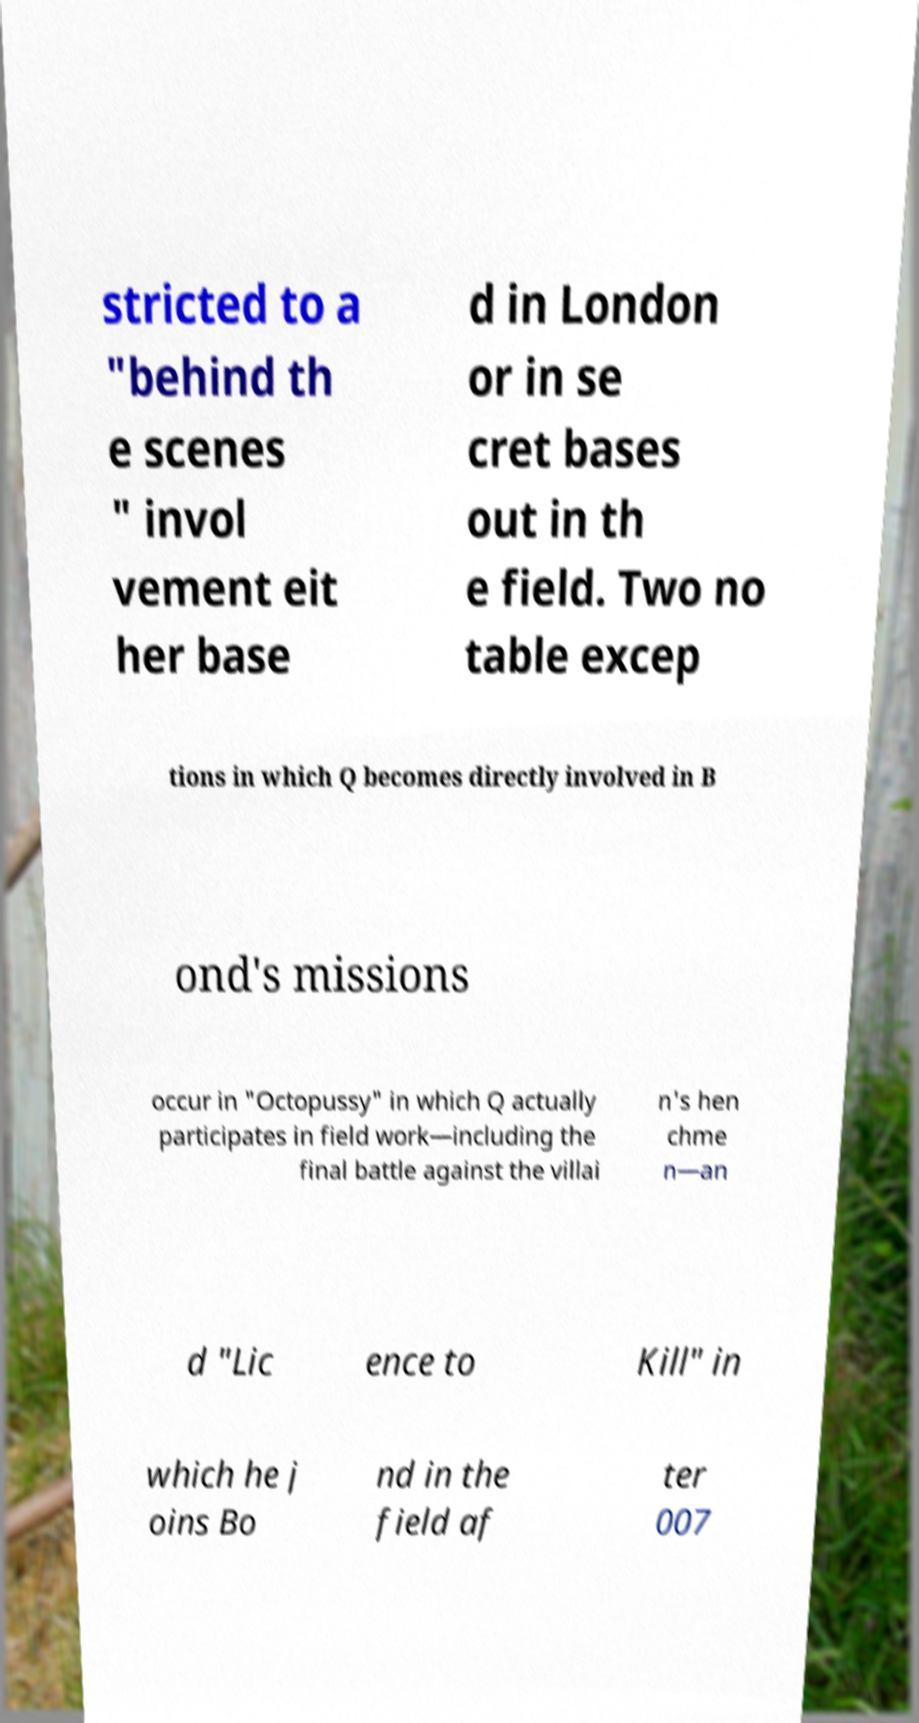Please read and relay the text visible in this image. What does it say? stricted to a "behind th e scenes " invol vement eit her base d in London or in se cret bases out in th e field. Two no table excep tions in which Q becomes directly involved in B ond's missions occur in "Octopussy" in which Q actually participates in field work—including the final battle against the villai n's hen chme n—an d "Lic ence to Kill" in which he j oins Bo nd in the field af ter 007 